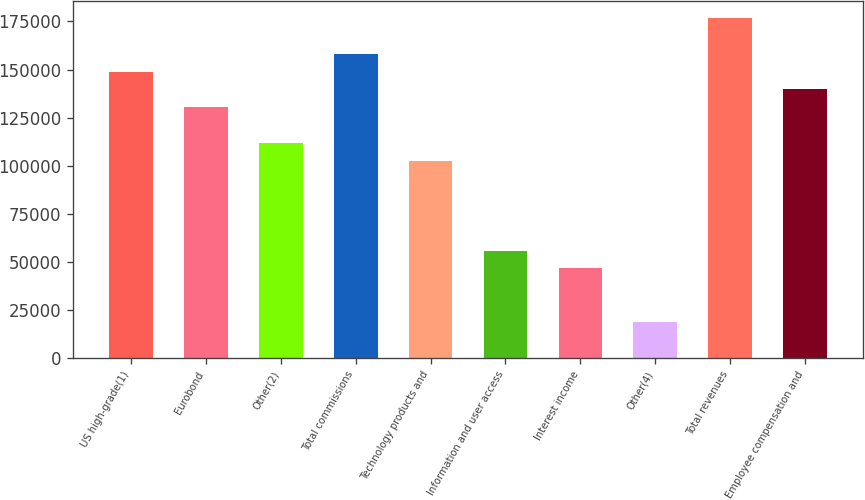<chart> <loc_0><loc_0><loc_500><loc_500><bar_chart><fcel>US high-grade(1)<fcel>Eurobond<fcel>Other(2)<fcel>Total commissions<fcel>Technology products and<fcel>Information and user access<fcel>Interest income<fcel>Other(4)<fcel>Total revenues<fcel>Employee compensation and<nl><fcel>148936<fcel>130319<fcel>111702<fcel>158244<fcel>102394<fcel>55851.1<fcel>46542.6<fcel>18617.2<fcel>176861<fcel>139627<nl></chart> 